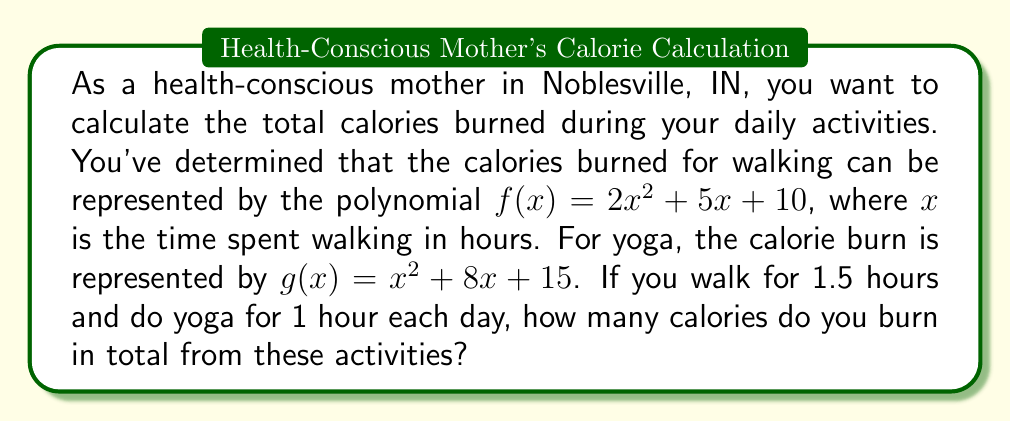Help me with this question. Let's break this down step-by-step:

1. For walking:
   - Time spent walking: $x = 1.5$ hours
   - Calories burned: $f(1.5) = 2(1.5)^2 + 5(1.5) + 10$
   
   Let's calculate:
   $$\begin{align}
   f(1.5) &= 2(1.5)^2 + 5(1.5) + 10 \\
   &= 2(2.25) + 7.5 + 10 \\
   &= 4.5 + 7.5 + 10 \\
   &= 22 \text{ calories}
   \end{align}$$

2. For yoga:
   - Time spent doing yoga: $x = 1$ hour
   - Calories burned: $g(1) = 1^2 + 8(1) + 15$
   
   Let's calculate:
   $$\begin{align}
   g(1) &= 1^2 + 8(1) + 15 \\
   &= 1 + 8 + 15 \\
   &= 24 \text{ calories}
   \end{align}$$

3. Total calories burned:
   - Add the calories from walking and yoga:
   $$\text{Total calories} = f(1.5) + g(1) = 22 + 24 = 46 \text{ calories}$$
Answer: 46 calories 